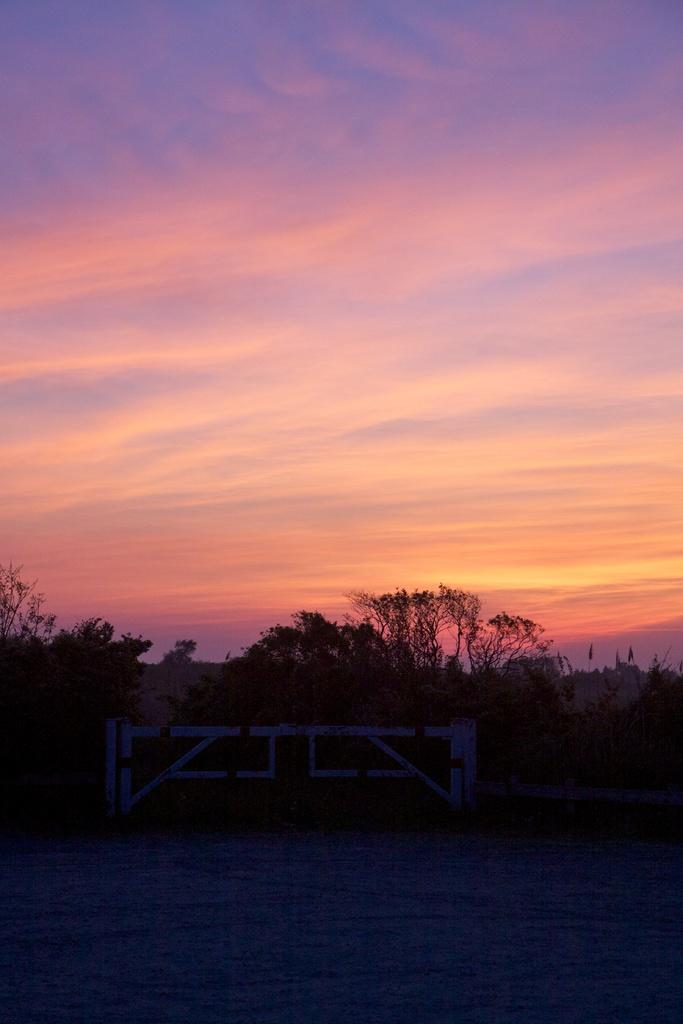Where was the image taken? The image was taken on a road. What can be seen beside the road? There is a wall beside the road. What feature is present in the wall? There is a gate in the center of the wall. What is visible behind the wall? Trees are visible behind the wall. What is visible at the top of the image? The sky is visible at the top of the image. What direction is the image facing, according to the north? The image does not indicate a specific direction, such as north, and the direction is not relevant to the image's content. Can you see any waves in the image? There are no waves present in the image; it features a road, wall, gate, trees, and sky. 